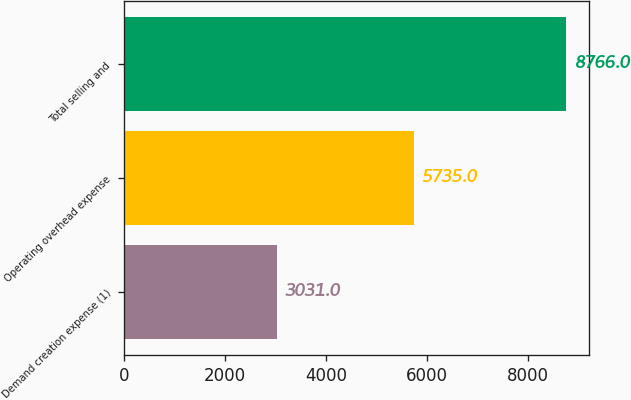Convert chart to OTSL. <chart><loc_0><loc_0><loc_500><loc_500><bar_chart><fcel>Demand creation expense (1)<fcel>Operating overhead expense<fcel>Total selling and<nl><fcel>3031<fcel>5735<fcel>8766<nl></chart> 